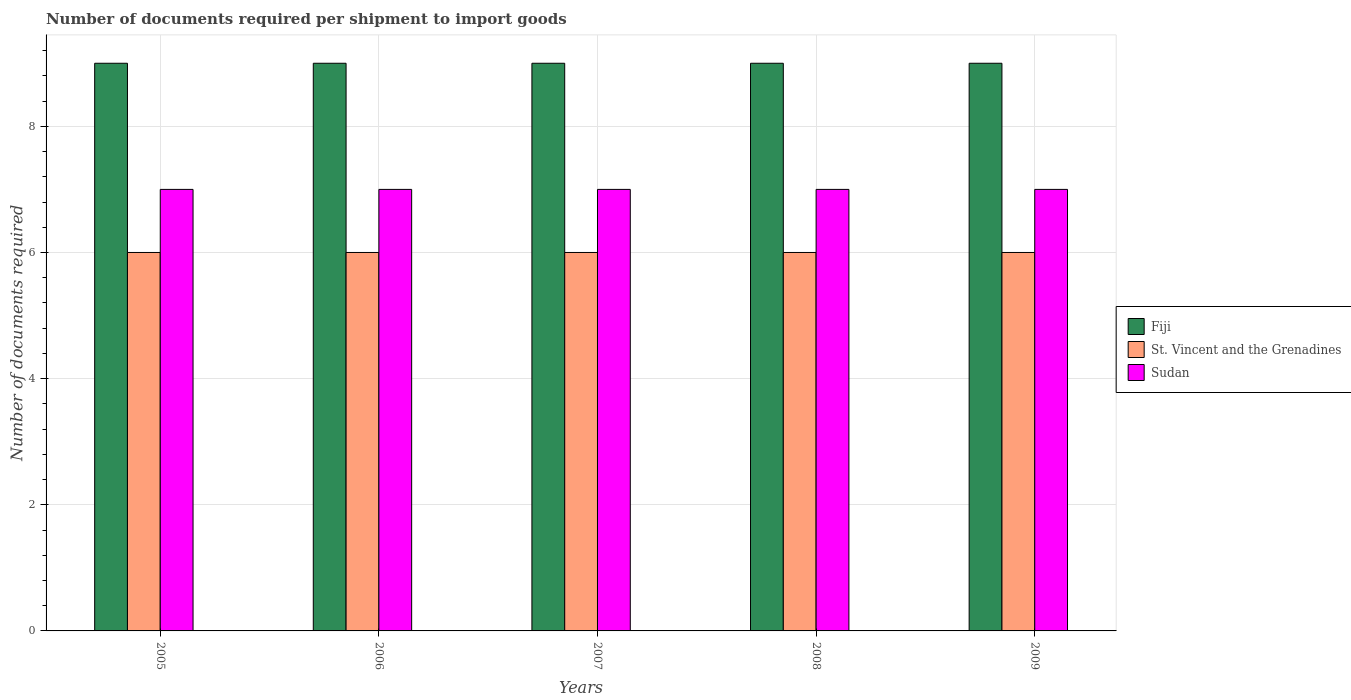How many different coloured bars are there?
Offer a very short reply. 3. How many groups of bars are there?
Make the answer very short. 5. Are the number of bars on each tick of the X-axis equal?
Offer a terse response. Yes. How many bars are there on the 3rd tick from the right?
Your answer should be compact. 3. What is the number of documents required per shipment to import goods in Fiji in 2005?
Provide a succinct answer. 9. Across all years, what is the maximum number of documents required per shipment to import goods in Sudan?
Your answer should be very brief. 7. What is the total number of documents required per shipment to import goods in St. Vincent and the Grenadines in the graph?
Your answer should be very brief. 30. What is the difference between the number of documents required per shipment to import goods in Fiji in 2005 and that in 2008?
Provide a short and direct response. 0. What is the difference between the number of documents required per shipment to import goods in Sudan in 2007 and the number of documents required per shipment to import goods in Fiji in 2009?
Provide a succinct answer. -2. What is the average number of documents required per shipment to import goods in Sudan per year?
Ensure brevity in your answer.  7. In the year 2006, what is the difference between the number of documents required per shipment to import goods in St. Vincent and the Grenadines and number of documents required per shipment to import goods in Sudan?
Your answer should be very brief. -1. What is the ratio of the number of documents required per shipment to import goods in Sudan in 2007 to that in 2008?
Your answer should be compact. 1. Is the number of documents required per shipment to import goods in Sudan in 2005 less than that in 2007?
Give a very brief answer. No. Is the difference between the number of documents required per shipment to import goods in St. Vincent and the Grenadines in 2006 and 2008 greater than the difference between the number of documents required per shipment to import goods in Sudan in 2006 and 2008?
Give a very brief answer. No. What does the 3rd bar from the left in 2008 represents?
Give a very brief answer. Sudan. What does the 1st bar from the right in 2005 represents?
Your answer should be compact. Sudan. Is it the case that in every year, the sum of the number of documents required per shipment to import goods in St. Vincent and the Grenadines and number of documents required per shipment to import goods in Fiji is greater than the number of documents required per shipment to import goods in Sudan?
Provide a succinct answer. Yes. How many years are there in the graph?
Provide a short and direct response. 5. Are the values on the major ticks of Y-axis written in scientific E-notation?
Offer a very short reply. No. Where does the legend appear in the graph?
Provide a succinct answer. Center right. How many legend labels are there?
Make the answer very short. 3. How are the legend labels stacked?
Keep it short and to the point. Vertical. What is the title of the graph?
Provide a succinct answer. Number of documents required per shipment to import goods. What is the label or title of the Y-axis?
Provide a succinct answer. Number of documents required. What is the Number of documents required in St. Vincent and the Grenadines in 2005?
Make the answer very short. 6. What is the Number of documents required in Fiji in 2006?
Provide a succinct answer. 9. What is the Number of documents required in St. Vincent and the Grenadines in 2007?
Offer a very short reply. 6. What is the Number of documents required of Sudan in 2007?
Provide a short and direct response. 7. What is the Number of documents required of Sudan in 2008?
Your answer should be compact. 7. What is the Number of documents required in Fiji in 2009?
Keep it short and to the point. 9. What is the Number of documents required of St. Vincent and the Grenadines in 2009?
Give a very brief answer. 6. Across all years, what is the maximum Number of documents required in Fiji?
Give a very brief answer. 9. Across all years, what is the maximum Number of documents required in St. Vincent and the Grenadines?
Your answer should be compact. 6. Across all years, what is the minimum Number of documents required of Sudan?
Your response must be concise. 7. What is the total Number of documents required in Fiji in the graph?
Your answer should be very brief. 45. What is the total Number of documents required in Sudan in the graph?
Your answer should be compact. 35. What is the difference between the Number of documents required of Fiji in 2005 and that in 2006?
Provide a short and direct response. 0. What is the difference between the Number of documents required of St. Vincent and the Grenadines in 2005 and that in 2006?
Your answer should be very brief. 0. What is the difference between the Number of documents required of Sudan in 2005 and that in 2006?
Ensure brevity in your answer.  0. What is the difference between the Number of documents required of St. Vincent and the Grenadines in 2005 and that in 2007?
Give a very brief answer. 0. What is the difference between the Number of documents required of Sudan in 2005 and that in 2007?
Make the answer very short. 0. What is the difference between the Number of documents required in Fiji in 2005 and that in 2008?
Your response must be concise. 0. What is the difference between the Number of documents required of St. Vincent and the Grenadines in 2005 and that in 2008?
Provide a succinct answer. 0. What is the difference between the Number of documents required in Sudan in 2005 and that in 2008?
Make the answer very short. 0. What is the difference between the Number of documents required of Fiji in 2005 and that in 2009?
Offer a terse response. 0. What is the difference between the Number of documents required of St. Vincent and the Grenadines in 2005 and that in 2009?
Your answer should be compact. 0. What is the difference between the Number of documents required in Sudan in 2005 and that in 2009?
Provide a succinct answer. 0. What is the difference between the Number of documents required of Fiji in 2006 and that in 2007?
Ensure brevity in your answer.  0. What is the difference between the Number of documents required of St. Vincent and the Grenadines in 2006 and that in 2007?
Ensure brevity in your answer.  0. What is the difference between the Number of documents required in Sudan in 2006 and that in 2007?
Your response must be concise. 0. What is the difference between the Number of documents required of Fiji in 2006 and that in 2008?
Provide a short and direct response. 0. What is the difference between the Number of documents required in Sudan in 2006 and that in 2008?
Keep it short and to the point. 0. What is the difference between the Number of documents required in Fiji in 2006 and that in 2009?
Make the answer very short. 0. What is the difference between the Number of documents required in St. Vincent and the Grenadines in 2006 and that in 2009?
Make the answer very short. 0. What is the difference between the Number of documents required in Fiji in 2007 and that in 2008?
Make the answer very short. 0. What is the difference between the Number of documents required of Sudan in 2007 and that in 2008?
Your answer should be compact. 0. What is the difference between the Number of documents required of Sudan in 2007 and that in 2009?
Provide a succinct answer. 0. What is the difference between the Number of documents required in St. Vincent and the Grenadines in 2008 and that in 2009?
Your response must be concise. 0. What is the difference between the Number of documents required in Fiji in 2005 and the Number of documents required in St. Vincent and the Grenadines in 2006?
Your response must be concise. 3. What is the difference between the Number of documents required of Fiji in 2005 and the Number of documents required of Sudan in 2006?
Ensure brevity in your answer.  2. What is the difference between the Number of documents required of Fiji in 2005 and the Number of documents required of St. Vincent and the Grenadines in 2007?
Your response must be concise. 3. What is the difference between the Number of documents required in Fiji in 2005 and the Number of documents required in St. Vincent and the Grenadines in 2008?
Give a very brief answer. 3. What is the difference between the Number of documents required in Fiji in 2005 and the Number of documents required in Sudan in 2008?
Ensure brevity in your answer.  2. What is the difference between the Number of documents required of Fiji in 2005 and the Number of documents required of Sudan in 2009?
Offer a very short reply. 2. What is the difference between the Number of documents required of St. Vincent and the Grenadines in 2005 and the Number of documents required of Sudan in 2009?
Your answer should be compact. -1. What is the difference between the Number of documents required in Fiji in 2006 and the Number of documents required in St. Vincent and the Grenadines in 2007?
Offer a very short reply. 3. What is the difference between the Number of documents required in Fiji in 2006 and the Number of documents required in Sudan in 2008?
Keep it short and to the point. 2. What is the difference between the Number of documents required in Fiji in 2006 and the Number of documents required in Sudan in 2009?
Offer a terse response. 2. What is the difference between the Number of documents required in Fiji in 2007 and the Number of documents required in St. Vincent and the Grenadines in 2008?
Offer a terse response. 3. What is the difference between the Number of documents required in Fiji in 2007 and the Number of documents required in Sudan in 2008?
Your answer should be compact. 2. What is the difference between the Number of documents required of St. Vincent and the Grenadines in 2007 and the Number of documents required of Sudan in 2008?
Offer a terse response. -1. What is the difference between the Number of documents required in Fiji in 2007 and the Number of documents required in St. Vincent and the Grenadines in 2009?
Give a very brief answer. 3. What is the difference between the Number of documents required in Fiji in 2008 and the Number of documents required in Sudan in 2009?
Give a very brief answer. 2. What is the difference between the Number of documents required of St. Vincent and the Grenadines in 2008 and the Number of documents required of Sudan in 2009?
Make the answer very short. -1. What is the average Number of documents required in Fiji per year?
Offer a terse response. 9. What is the average Number of documents required of Sudan per year?
Make the answer very short. 7. In the year 2005, what is the difference between the Number of documents required of Fiji and Number of documents required of Sudan?
Provide a short and direct response. 2. In the year 2006, what is the difference between the Number of documents required in Fiji and Number of documents required in Sudan?
Provide a short and direct response. 2. In the year 2006, what is the difference between the Number of documents required in St. Vincent and the Grenadines and Number of documents required in Sudan?
Offer a terse response. -1. In the year 2007, what is the difference between the Number of documents required in Fiji and Number of documents required in Sudan?
Ensure brevity in your answer.  2. In the year 2008, what is the difference between the Number of documents required in Fiji and Number of documents required in St. Vincent and the Grenadines?
Make the answer very short. 3. In the year 2008, what is the difference between the Number of documents required in Fiji and Number of documents required in Sudan?
Your response must be concise. 2. In the year 2009, what is the difference between the Number of documents required of St. Vincent and the Grenadines and Number of documents required of Sudan?
Ensure brevity in your answer.  -1. What is the ratio of the Number of documents required in Fiji in 2005 to that in 2006?
Offer a terse response. 1. What is the ratio of the Number of documents required in St. Vincent and the Grenadines in 2005 to that in 2007?
Offer a terse response. 1. What is the ratio of the Number of documents required of Sudan in 2005 to that in 2007?
Make the answer very short. 1. What is the ratio of the Number of documents required in Sudan in 2005 to that in 2008?
Give a very brief answer. 1. What is the ratio of the Number of documents required of Fiji in 2005 to that in 2009?
Your response must be concise. 1. What is the ratio of the Number of documents required of St. Vincent and the Grenadines in 2005 to that in 2009?
Provide a short and direct response. 1. What is the ratio of the Number of documents required of Sudan in 2005 to that in 2009?
Your response must be concise. 1. What is the ratio of the Number of documents required in St. Vincent and the Grenadines in 2006 to that in 2007?
Keep it short and to the point. 1. What is the ratio of the Number of documents required in Fiji in 2006 to that in 2008?
Provide a short and direct response. 1. What is the ratio of the Number of documents required of Sudan in 2006 to that in 2008?
Your answer should be compact. 1. What is the ratio of the Number of documents required in St. Vincent and the Grenadines in 2006 to that in 2009?
Your response must be concise. 1. What is the ratio of the Number of documents required in St. Vincent and the Grenadines in 2007 to that in 2008?
Make the answer very short. 1. What is the ratio of the Number of documents required in Fiji in 2008 to that in 2009?
Provide a short and direct response. 1. What is the ratio of the Number of documents required of Sudan in 2008 to that in 2009?
Make the answer very short. 1. 